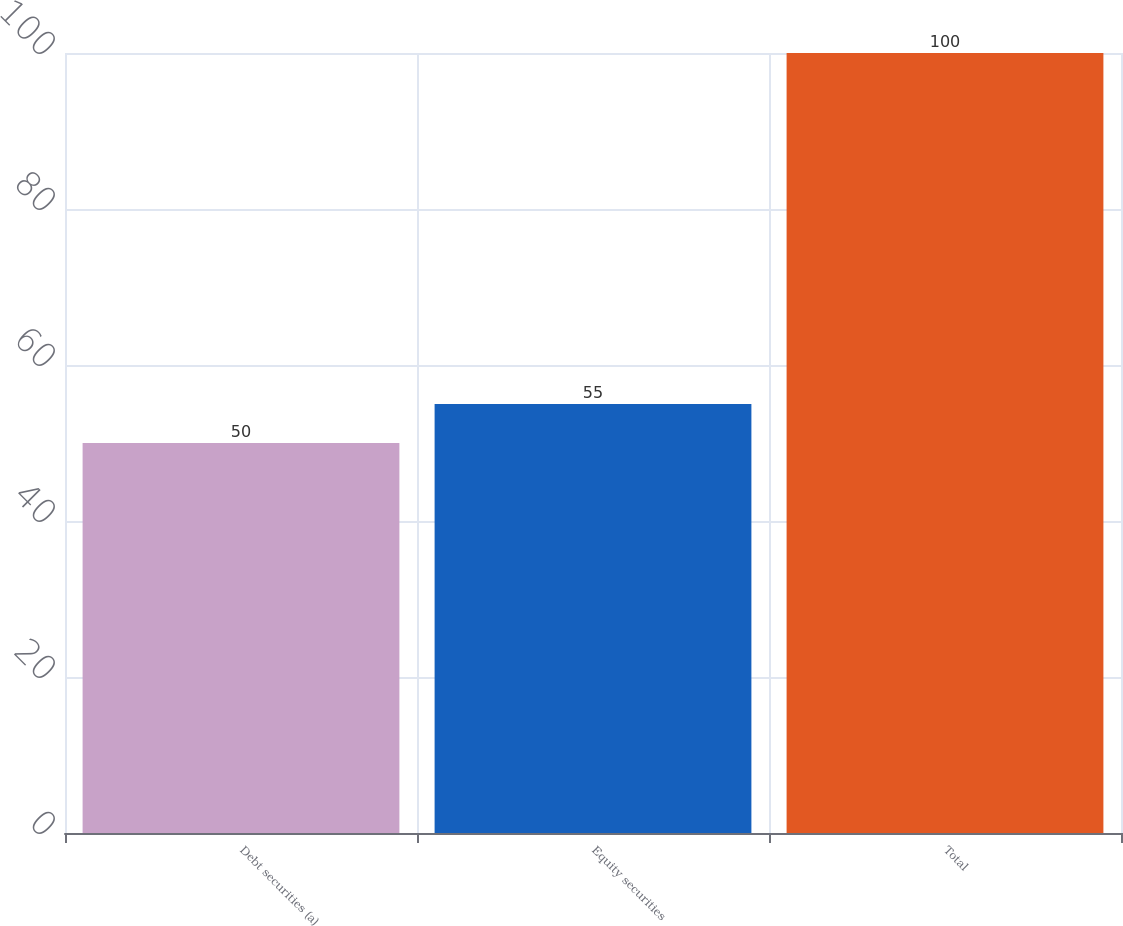<chart> <loc_0><loc_0><loc_500><loc_500><bar_chart><fcel>Debt securities (a)<fcel>Equity securities<fcel>Total<nl><fcel>50<fcel>55<fcel>100<nl></chart> 